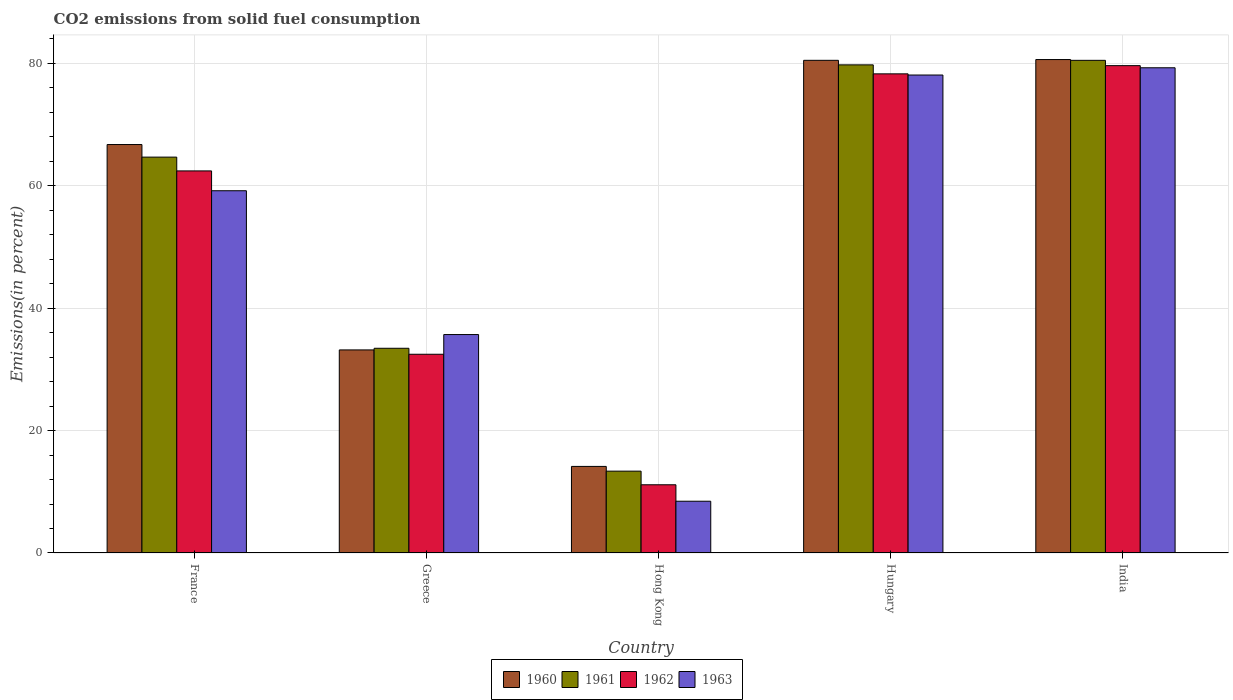Are the number of bars on each tick of the X-axis equal?
Your answer should be very brief. Yes. What is the label of the 4th group of bars from the left?
Give a very brief answer. Hungary. In how many cases, is the number of bars for a given country not equal to the number of legend labels?
Your response must be concise. 0. What is the total CO2 emitted in 1961 in India?
Offer a terse response. 80.49. Across all countries, what is the maximum total CO2 emitted in 1961?
Your answer should be very brief. 80.49. Across all countries, what is the minimum total CO2 emitted in 1963?
Provide a succinct answer. 8.46. In which country was the total CO2 emitted in 1963 maximum?
Provide a short and direct response. India. In which country was the total CO2 emitted in 1961 minimum?
Your response must be concise. Hong Kong. What is the total total CO2 emitted in 1960 in the graph?
Make the answer very short. 275.16. What is the difference between the total CO2 emitted in 1962 in Hong Kong and that in India?
Keep it short and to the point. -68.47. What is the difference between the total CO2 emitted in 1963 in Greece and the total CO2 emitted in 1960 in India?
Ensure brevity in your answer.  -44.93. What is the average total CO2 emitted in 1962 per country?
Keep it short and to the point. 52.79. What is the difference between the total CO2 emitted of/in 1963 and total CO2 emitted of/in 1962 in Greece?
Your response must be concise. 3.22. In how many countries, is the total CO2 emitted in 1961 greater than 60 %?
Make the answer very short. 3. What is the ratio of the total CO2 emitted in 1962 in Greece to that in India?
Provide a succinct answer. 0.41. What is the difference between the highest and the second highest total CO2 emitted in 1960?
Keep it short and to the point. 13.88. What is the difference between the highest and the lowest total CO2 emitted in 1960?
Provide a succinct answer. 66.47. In how many countries, is the total CO2 emitted in 1963 greater than the average total CO2 emitted in 1963 taken over all countries?
Provide a short and direct response. 3. Is it the case that in every country, the sum of the total CO2 emitted in 1963 and total CO2 emitted in 1962 is greater than the sum of total CO2 emitted in 1960 and total CO2 emitted in 1961?
Keep it short and to the point. No. What does the 3rd bar from the left in Greece represents?
Provide a succinct answer. 1962. Is it the case that in every country, the sum of the total CO2 emitted in 1961 and total CO2 emitted in 1962 is greater than the total CO2 emitted in 1960?
Offer a very short reply. Yes. How many countries are there in the graph?
Keep it short and to the point. 5. Does the graph contain grids?
Make the answer very short. Yes. Where does the legend appear in the graph?
Offer a very short reply. Bottom center. How many legend labels are there?
Provide a short and direct response. 4. What is the title of the graph?
Offer a very short reply. CO2 emissions from solid fuel consumption. What is the label or title of the X-axis?
Your answer should be compact. Country. What is the label or title of the Y-axis?
Make the answer very short. Emissions(in percent). What is the Emissions(in percent) in 1960 in France?
Provide a succinct answer. 66.73. What is the Emissions(in percent) of 1961 in France?
Offer a terse response. 64.68. What is the Emissions(in percent) of 1962 in France?
Your response must be concise. 62.42. What is the Emissions(in percent) in 1963 in France?
Ensure brevity in your answer.  59.18. What is the Emissions(in percent) in 1960 in Greece?
Ensure brevity in your answer.  33.18. What is the Emissions(in percent) of 1961 in Greece?
Your response must be concise. 33.45. What is the Emissions(in percent) in 1962 in Greece?
Offer a terse response. 32.47. What is the Emissions(in percent) of 1963 in Greece?
Provide a short and direct response. 35.69. What is the Emissions(in percent) of 1960 in Hong Kong?
Keep it short and to the point. 14.14. What is the Emissions(in percent) in 1961 in Hong Kong?
Offer a terse response. 13.37. What is the Emissions(in percent) of 1962 in Hong Kong?
Ensure brevity in your answer.  11.14. What is the Emissions(in percent) of 1963 in Hong Kong?
Make the answer very short. 8.46. What is the Emissions(in percent) of 1960 in Hungary?
Keep it short and to the point. 80.49. What is the Emissions(in percent) of 1961 in Hungary?
Your answer should be very brief. 79.75. What is the Emissions(in percent) of 1962 in Hungary?
Provide a short and direct response. 78.28. What is the Emissions(in percent) in 1963 in Hungary?
Offer a very short reply. 78.09. What is the Emissions(in percent) of 1960 in India?
Ensure brevity in your answer.  80.62. What is the Emissions(in percent) of 1961 in India?
Offer a terse response. 80.49. What is the Emissions(in percent) in 1962 in India?
Keep it short and to the point. 79.62. What is the Emissions(in percent) of 1963 in India?
Provide a short and direct response. 79.27. Across all countries, what is the maximum Emissions(in percent) of 1960?
Your answer should be very brief. 80.62. Across all countries, what is the maximum Emissions(in percent) in 1961?
Provide a succinct answer. 80.49. Across all countries, what is the maximum Emissions(in percent) in 1962?
Provide a short and direct response. 79.62. Across all countries, what is the maximum Emissions(in percent) of 1963?
Provide a succinct answer. 79.27. Across all countries, what is the minimum Emissions(in percent) in 1960?
Your answer should be compact. 14.14. Across all countries, what is the minimum Emissions(in percent) in 1961?
Your response must be concise. 13.37. Across all countries, what is the minimum Emissions(in percent) of 1962?
Your response must be concise. 11.14. Across all countries, what is the minimum Emissions(in percent) of 1963?
Ensure brevity in your answer.  8.46. What is the total Emissions(in percent) of 1960 in the graph?
Ensure brevity in your answer.  275.16. What is the total Emissions(in percent) of 1961 in the graph?
Give a very brief answer. 271.72. What is the total Emissions(in percent) of 1962 in the graph?
Your answer should be very brief. 263.93. What is the total Emissions(in percent) in 1963 in the graph?
Your answer should be compact. 260.68. What is the difference between the Emissions(in percent) in 1960 in France and that in Greece?
Offer a very short reply. 33.55. What is the difference between the Emissions(in percent) of 1961 in France and that in Greece?
Your answer should be very brief. 31.23. What is the difference between the Emissions(in percent) of 1962 in France and that in Greece?
Offer a very short reply. 29.95. What is the difference between the Emissions(in percent) in 1963 in France and that in Greece?
Keep it short and to the point. 23.49. What is the difference between the Emissions(in percent) of 1960 in France and that in Hong Kong?
Keep it short and to the point. 52.59. What is the difference between the Emissions(in percent) in 1961 in France and that in Hong Kong?
Your answer should be compact. 51.31. What is the difference between the Emissions(in percent) in 1962 in France and that in Hong Kong?
Ensure brevity in your answer.  51.28. What is the difference between the Emissions(in percent) in 1963 in France and that in Hong Kong?
Ensure brevity in your answer.  50.73. What is the difference between the Emissions(in percent) of 1960 in France and that in Hungary?
Keep it short and to the point. -13.76. What is the difference between the Emissions(in percent) in 1961 in France and that in Hungary?
Provide a short and direct response. -15.07. What is the difference between the Emissions(in percent) of 1962 in France and that in Hungary?
Provide a short and direct response. -15.86. What is the difference between the Emissions(in percent) of 1963 in France and that in Hungary?
Your response must be concise. -18.91. What is the difference between the Emissions(in percent) of 1960 in France and that in India?
Make the answer very short. -13.88. What is the difference between the Emissions(in percent) in 1961 in France and that in India?
Keep it short and to the point. -15.81. What is the difference between the Emissions(in percent) in 1962 in France and that in India?
Provide a short and direct response. -17.2. What is the difference between the Emissions(in percent) of 1963 in France and that in India?
Ensure brevity in your answer.  -20.09. What is the difference between the Emissions(in percent) in 1960 in Greece and that in Hong Kong?
Provide a short and direct response. 19.03. What is the difference between the Emissions(in percent) in 1961 in Greece and that in Hong Kong?
Provide a succinct answer. 20.08. What is the difference between the Emissions(in percent) of 1962 in Greece and that in Hong Kong?
Offer a terse response. 21.32. What is the difference between the Emissions(in percent) in 1963 in Greece and that in Hong Kong?
Offer a terse response. 27.23. What is the difference between the Emissions(in percent) in 1960 in Greece and that in Hungary?
Provide a short and direct response. -47.31. What is the difference between the Emissions(in percent) in 1961 in Greece and that in Hungary?
Your answer should be very brief. -46.3. What is the difference between the Emissions(in percent) of 1962 in Greece and that in Hungary?
Keep it short and to the point. -45.81. What is the difference between the Emissions(in percent) of 1963 in Greece and that in Hungary?
Ensure brevity in your answer.  -42.4. What is the difference between the Emissions(in percent) in 1960 in Greece and that in India?
Offer a terse response. -47.44. What is the difference between the Emissions(in percent) in 1961 in Greece and that in India?
Your response must be concise. -47.04. What is the difference between the Emissions(in percent) in 1962 in Greece and that in India?
Offer a very short reply. -47.15. What is the difference between the Emissions(in percent) in 1963 in Greece and that in India?
Keep it short and to the point. -43.58. What is the difference between the Emissions(in percent) in 1960 in Hong Kong and that in Hungary?
Make the answer very short. -66.35. What is the difference between the Emissions(in percent) of 1961 in Hong Kong and that in Hungary?
Provide a short and direct response. -66.38. What is the difference between the Emissions(in percent) in 1962 in Hong Kong and that in Hungary?
Give a very brief answer. -67.13. What is the difference between the Emissions(in percent) in 1963 in Hong Kong and that in Hungary?
Keep it short and to the point. -69.63. What is the difference between the Emissions(in percent) in 1960 in Hong Kong and that in India?
Provide a succinct answer. -66.47. What is the difference between the Emissions(in percent) of 1961 in Hong Kong and that in India?
Keep it short and to the point. -67.12. What is the difference between the Emissions(in percent) of 1962 in Hong Kong and that in India?
Give a very brief answer. -68.47. What is the difference between the Emissions(in percent) of 1963 in Hong Kong and that in India?
Keep it short and to the point. -70.82. What is the difference between the Emissions(in percent) of 1960 in Hungary and that in India?
Provide a succinct answer. -0.13. What is the difference between the Emissions(in percent) of 1961 in Hungary and that in India?
Your answer should be very brief. -0.74. What is the difference between the Emissions(in percent) in 1962 in Hungary and that in India?
Provide a short and direct response. -1.34. What is the difference between the Emissions(in percent) in 1963 in Hungary and that in India?
Offer a terse response. -1.18. What is the difference between the Emissions(in percent) in 1960 in France and the Emissions(in percent) in 1961 in Greece?
Your answer should be very brief. 33.29. What is the difference between the Emissions(in percent) of 1960 in France and the Emissions(in percent) of 1962 in Greece?
Provide a succinct answer. 34.26. What is the difference between the Emissions(in percent) in 1960 in France and the Emissions(in percent) in 1963 in Greece?
Your answer should be compact. 31.05. What is the difference between the Emissions(in percent) of 1961 in France and the Emissions(in percent) of 1962 in Greece?
Keep it short and to the point. 32.21. What is the difference between the Emissions(in percent) of 1961 in France and the Emissions(in percent) of 1963 in Greece?
Offer a terse response. 28.99. What is the difference between the Emissions(in percent) in 1962 in France and the Emissions(in percent) in 1963 in Greece?
Make the answer very short. 26.74. What is the difference between the Emissions(in percent) of 1960 in France and the Emissions(in percent) of 1961 in Hong Kong?
Make the answer very short. 53.36. What is the difference between the Emissions(in percent) of 1960 in France and the Emissions(in percent) of 1962 in Hong Kong?
Provide a succinct answer. 55.59. What is the difference between the Emissions(in percent) of 1960 in France and the Emissions(in percent) of 1963 in Hong Kong?
Your answer should be compact. 58.28. What is the difference between the Emissions(in percent) in 1961 in France and the Emissions(in percent) in 1962 in Hong Kong?
Ensure brevity in your answer.  53.53. What is the difference between the Emissions(in percent) of 1961 in France and the Emissions(in percent) of 1963 in Hong Kong?
Provide a short and direct response. 56.22. What is the difference between the Emissions(in percent) of 1962 in France and the Emissions(in percent) of 1963 in Hong Kong?
Provide a succinct answer. 53.97. What is the difference between the Emissions(in percent) of 1960 in France and the Emissions(in percent) of 1961 in Hungary?
Keep it short and to the point. -13.02. What is the difference between the Emissions(in percent) in 1960 in France and the Emissions(in percent) in 1962 in Hungary?
Your answer should be compact. -11.55. What is the difference between the Emissions(in percent) in 1960 in France and the Emissions(in percent) in 1963 in Hungary?
Your answer should be compact. -11.36. What is the difference between the Emissions(in percent) in 1961 in France and the Emissions(in percent) in 1962 in Hungary?
Give a very brief answer. -13.6. What is the difference between the Emissions(in percent) in 1961 in France and the Emissions(in percent) in 1963 in Hungary?
Offer a terse response. -13.41. What is the difference between the Emissions(in percent) of 1962 in France and the Emissions(in percent) of 1963 in Hungary?
Ensure brevity in your answer.  -15.67. What is the difference between the Emissions(in percent) of 1960 in France and the Emissions(in percent) of 1961 in India?
Give a very brief answer. -13.76. What is the difference between the Emissions(in percent) in 1960 in France and the Emissions(in percent) in 1962 in India?
Offer a terse response. -12.89. What is the difference between the Emissions(in percent) of 1960 in France and the Emissions(in percent) of 1963 in India?
Make the answer very short. -12.54. What is the difference between the Emissions(in percent) of 1961 in France and the Emissions(in percent) of 1962 in India?
Ensure brevity in your answer.  -14.94. What is the difference between the Emissions(in percent) in 1961 in France and the Emissions(in percent) in 1963 in India?
Offer a very short reply. -14.6. What is the difference between the Emissions(in percent) in 1962 in France and the Emissions(in percent) in 1963 in India?
Offer a terse response. -16.85. What is the difference between the Emissions(in percent) in 1960 in Greece and the Emissions(in percent) in 1961 in Hong Kong?
Keep it short and to the point. 19.81. What is the difference between the Emissions(in percent) in 1960 in Greece and the Emissions(in percent) in 1962 in Hong Kong?
Make the answer very short. 22.03. What is the difference between the Emissions(in percent) of 1960 in Greece and the Emissions(in percent) of 1963 in Hong Kong?
Your response must be concise. 24.72. What is the difference between the Emissions(in percent) in 1961 in Greece and the Emissions(in percent) in 1962 in Hong Kong?
Ensure brevity in your answer.  22.3. What is the difference between the Emissions(in percent) in 1961 in Greece and the Emissions(in percent) in 1963 in Hong Kong?
Provide a succinct answer. 24.99. What is the difference between the Emissions(in percent) of 1962 in Greece and the Emissions(in percent) of 1963 in Hong Kong?
Give a very brief answer. 24.01. What is the difference between the Emissions(in percent) in 1960 in Greece and the Emissions(in percent) in 1961 in Hungary?
Give a very brief answer. -46.57. What is the difference between the Emissions(in percent) of 1960 in Greece and the Emissions(in percent) of 1962 in Hungary?
Your answer should be compact. -45.1. What is the difference between the Emissions(in percent) of 1960 in Greece and the Emissions(in percent) of 1963 in Hungary?
Give a very brief answer. -44.91. What is the difference between the Emissions(in percent) of 1961 in Greece and the Emissions(in percent) of 1962 in Hungary?
Give a very brief answer. -44.83. What is the difference between the Emissions(in percent) in 1961 in Greece and the Emissions(in percent) in 1963 in Hungary?
Provide a short and direct response. -44.64. What is the difference between the Emissions(in percent) in 1962 in Greece and the Emissions(in percent) in 1963 in Hungary?
Your answer should be very brief. -45.62. What is the difference between the Emissions(in percent) of 1960 in Greece and the Emissions(in percent) of 1961 in India?
Ensure brevity in your answer.  -47.31. What is the difference between the Emissions(in percent) of 1960 in Greece and the Emissions(in percent) of 1962 in India?
Provide a succinct answer. -46.44. What is the difference between the Emissions(in percent) of 1960 in Greece and the Emissions(in percent) of 1963 in India?
Keep it short and to the point. -46.09. What is the difference between the Emissions(in percent) of 1961 in Greece and the Emissions(in percent) of 1962 in India?
Ensure brevity in your answer.  -46.17. What is the difference between the Emissions(in percent) in 1961 in Greece and the Emissions(in percent) in 1963 in India?
Provide a succinct answer. -45.83. What is the difference between the Emissions(in percent) in 1962 in Greece and the Emissions(in percent) in 1963 in India?
Provide a succinct answer. -46.8. What is the difference between the Emissions(in percent) in 1960 in Hong Kong and the Emissions(in percent) in 1961 in Hungary?
Keep it short and to the point. -65.6. What is the difference between the Emissions(in percent) of 1960 in Hong Kong and the Emissions(in percent) of 1962 in Hungary?
Make the answer very short. -64.13. What is the difference between the Emissions(in percent) in 1960 in Hong Kong and the Emissions(in percent) in 1963 in Hungary?
Keep it short and to the point. -63.94. What is the difference between the Emissions(in percent) of 1961 in Hong Kong and the Emissions(in percent) of 1962 in Hungary?
Keep it short and to the point. -64.91. What is the difference between the Emissions(in percent) in 1961 in Hong Kong and the Emissions(in percent) in 1963 in Hungary?
Make the answer very short. -64.72. What is the difference between the Emissions(in percent) in 1962 in Hong Kong and the Emissions(in percent) in 1963 in Hungary?
Your answer should be very brief. -66.94. What is the difference between the Emissions(in percent) of 1960 in Hong Kong and the Emissions(in percent) of 1961 in India?
Your answer should be compact. -66.34. What is the difference between the Emissions(in percent) of 1960 in Hong Kong and the Emissions(in percent) of 1962 in India?
Keep it short and to the point. -65.47. What is the difference between the Emissions(in percent) of 1960 in Hong Kong and the Emissions(in percent) of 1963 in India?
Offer a very short reply. -65.13. What is the difference between the Emissions(in percent) of 1961 in Hong Kong and the Emissions(in percent) of 1962 in India?
Provide a short and direct response. -66.25. What is the difference between the Emissions(in percent) of 1961 in Hong Kong and the Emissions(in percent) of 1963 in India?
Provide a short and direct response. -65.9. What is the difference between the Emissions(in percent) in 1962 in Hong Kong and the Emissions(in percent) in 1963 in India?
Provide a succinct answer. -68.13. What is the difference between the Emissions(in percent) in 1960 in Hungary and the Emissions(in percent) in 1961 in India?
Give a very brief answer. 0. What is the difference between the Emissions(in percent) in 1960 in Hungary and the Emissions(in percent) in 1962 in India?
Keep it short and to the point. 0.87. What is the difference between the Emissions(in percent) in 1960 in Hungary and the Emissions(in percent) in 1963 in India?
Ensure brevity in your answer.  1.22. What is the difference between the Emissions(in percent) of 1961 in Hungary and the Emissions(in percent) of 1962 in India?
Offer a terse response. 0.13. What is the difference between the Emissions(in percent) of 1961 in Hungary and the Emissions(in percent) of 1963 in India?
Provide a short and direct response. 0.48. What is the difference between the Emissions(in percent) in 1962 in Hungary and the Emissions(in percent) in 1963 in India?
Keep it short and to the point. -0.99. What is the average Emissions(in percent) in 1960 per country?
Make the answer very short. 55.03. What is the average Emissions(in percent) in 1961 per country?
Your response must be concise. 54.34. What is the average Emissions(in percent) of 1962 per country?
Keep it short and to the point. 52.79. What is the average Emissions(in percent) of 1963 per country?
Provide a succinct answer. 52.14. What is the difference between the Emissions(in percent) in 1960 and Emissions(in percent) in 1961 in France?
Provide a short and direct response. 2.06. What is the difference between the Emissions(in percent) of 1960 and Emissions(in percent) of 1962 in France?
Offer a terse response. 4.31. What is the difference between the Emissions(in percent) in 1960 and Emissions(in percent) in 1963 in France?
Your response must be concise. 7.55. What is the difference between the Emissions(in percent) in 1961 and Emissions(in percent) in 1962 in France?
Your answer should be very brief. 2.25. What is the difference between the Emissions(in percent) in 1961 and Emissions(in percent) in 1963 in France?
Provide a succinct answer. 5.49. What is the difference between the Emissions(in percent) of 1962 and Emissions(in percent) of 1963 in France?
Make the answer very short. 3.24. What is the difference between the Emissions(in percent) of 1960 and Emissions(in percent) of 1961 in Greece?
Keep it short and to the point. -0.27. What is the difference between the Emissions(in percent) in 1960 and Emissions(in percent) in 1962 in Greece?
Offer a terse response. 0.71. What is the difference between the Emissions(in percent) in 1960 and Emissions(in percent) in 1963 in Greece?
Provide a short and direct response. -2.51. What is the difference between the Emissions(in percent) of 1961 and Emissions(in percent) of 1962 in Greece?
Provide a succinct answer. 0.98. What is the difference between the Emissions(in percent) of 1961 and Emissions(in percent) of 1963 in Greece?
Make the answer very short. -2.24. What is the difference between the Emissions(in percent) in 1962 and Emissions(in percent) in 1963 in Greece?
Keep it short and to the point. -3.22. What is the difference between the Emissions(in percent) of 1960 and Emissions(in percent) of 1961 in Hong Kong?
Provide a succinct answer. 0.77. What is the difference between the Emissions(in percent) in 1960 and Emissions(in percent) in 1962 in Hong Kong?
Your answer should be compact. 3. What is the difference between the Emissions(in percent) of 1960 and Emissions(in percent) of 1963 in Hong Kong?
Your answer should be very brief. 5.69. What is the difference between the Emissions(in percent) in 1961 and Emissions(in percent) in 1962 in Hong Kong?
Make the answer very short. 2.23. What is the difference between the Emissions(in percent) of 1961 and Emissions(in percent) of 1963 in Hong Kong?
Ensure brevity in your answer.  4.91. What is the difference between the Emissions(in percent) in 1962 and Emissions(in percent) in 1963 in Hong Kong?
Provide a succinct answer. 2.69. What is the difference between the Emissions(in percent) in 1960 and Emissions(in percent) in 1961 in Hungary?
Provide a short and direct response. 0.74. What is the difference between the Emissions(in percent) of 1960 and Emissions(in percent) of 1962 in Hungary?
Make the answer very short. 2.21. What is the difference between the Emissions(in percent) in 1960 and Emissions(in percent) in 1963 in Hungary?
Provide a succinct answer. 2.4. What is the difference between the Emissions(in percent) of 1961 and Emissions(in percent) of 1962 in Hungary?
Offer a terse response. 1.47. What is the difference between the Emissions(in percent) in 1961 and Emissions(in percent) in 1963 in Hungary?
Make the answer very short. 1.66. What is the difference between the Emissions(in percent) in 1962 and Emissions(in percent) in 1963 in Hungary?
Keep it short and to the point. 0.19. What is the difference between the Emissions(in percent) of 1960 and Emissions(in percent) of 1961 in India?
Give a very brief answer. 0.13. What is the difference between the Emissions(in percent) of 1960 and Emissions(in percent) of 1962 in India?
Provide a succinct answer. 1. What is the difference between the Emissions(in percent) in 1960 and Emissions(in percent) in 1963 in India?
Provide a succinct answer. 1.34. What is the difference between the Emissions(in percent) in 1961 and Emissions(in percent) in 1962 in India?
Keep it short and to the point. 0.87. What is the difference between the Emissions(in percent) in 1961 and Emissions(in percent) in 1963 in India?
Provide a succinct answer. 1.22. What is the difference between the Emissions(in percent) of 1962 and Emissions(in percent) of 1963 in India?
Offer a very short reply. 0.35. What is the ratio of the Emissions(in percent) in 1960 in France to that in Greece?
Offer a terse response. 2.01. What is the ratio of the Emissions(in percent) of 1961 in France to that in Greece?
Offer a terse response. 1.93. What is the ratio of the Emissions(in percent) in 1962 in France to that in Greece?
Give a very brief answer. 1.92. What is the ratio of the Emissions(in percent) in 1963 in France to that in Greece?
Your response must be concise. 1.66. What is the ratio of the Emissions(in percent) of 1960 in France to that in Hong Kong?
Keep it short and to the point. 4.72. What is the ratio of the Emissions(in percent) of 1961 in France to that in Hong Kong?
Your answer should be compact. 4.84. What is the ratio of the Emissions(in percent) in 1962 in France to that in Hong Kong?
Provide a short and direct response. 5.6. What is the ratio of the Emissions(in percent) in 1963 in France to that in Hong Kong?
Provide a short and direct response. 7. What is the ratio of the Emissions(in percent) of 1960 in France to that in Hungary?
Ensure brevity in your answer.  0.83. What is the ratio of the Emissions(in percent) of 1961 in France to that in Hungary?
Your response must be concise. 0.81. What is the ratio of the Emissions(in percent) in 1962 in France to that in Hungary?
Make the answer very short. 0.8. What is the ratio of the Emissions(in percent) of 1963 in France to that in Hungary?
Keep it short and to the point. 0.76. What is the ratio of the Emissions(in percent) in 1960 in France to that in India?
Give a very brief answer. 0.83. What is the ratio of the Emissions(in percent) in 1961 in France to that in India?
Provide a short and direct response. 0.8. What is the ratio of the Emissions(in percent) of 1962 in France to that in India?
Ensure brevity in your answer.  0.78. What is the ratio of the Emissions(in percent) of 1963 in France to that in India?
Give a very brief answer. 0.75. What is the ratio of the Emissions(in percent) in 1960 in Greece to that in Hong Kong?
Your answer should be compact. 2.35. What is the ratio of the Emissions(in percent) of 1961 in Greece to that in Hong Kong?
Offer a terse response. 2.5. What is the ratio of the Emissions(in percent) in 1962 in Greece to that in Hong Kong?
Keep it short and to the point. 2.91. What is the ratio of the Emissions(in percent) in 1963 in Greece to that in Hong Kong?
Make the answer very short. 4.22. What is the ratio of the Emissions(in percent) of 1960 in Greece to that in Hungary?
Make the answer very short. 0.41. What is the ratio of the Emissions(in percent) of 1961 in Greece to that in Hungary?
Provide a succinct answer. 0.42. What is the ratio of the Emissions(in percent) of 1962 in Greece to that in Hungary?
Your response must be concise. 0.41. What is the ratio of the Emissions(in percent) in 1963 in Greece to that in Hungary?
Keep it short and to the point. 0.46. What is the ratio of the Emissions(in percent) of 1960 in Greece to that in India?
Provide a succinct answer. 0.41. What is the ratio of the Emissions(in percent) in 1961 in Greece to that in India?
Offer a terse response. 0.42. What is the ratio of the Emissions(in percent) of 1962 in Greece to that in India?
Ensure brevity in your answer.  0.41. What is the ratio of the Emissions(in percent) of 1963 in Greece to that in India?
Your answer should be compact. 0.45. What is the ratio of the Emissions(in percent) in 1960 in Hong Kong to that in Hungary?
Make the answer very short. 0.18. What is the ratio of the Emissions(in percent) in 1961 in Hong Kong to that in Hungary?
Ensure brevity in your answer.  0.17. What is the ratio of the Emissions(in percent) in 1962 in Hong Kong to that in Hungary?
Keep it short and to the point. 0.14. What is the ratio of the Emissions(in percent) in 1963 in Hong Kong to that in Hungary?
Your answer should be very brief. 0.11. What is the ratio of the Emissions(in percent) in 1960 in Hong Kong to that in India?
Your response must be concise. 0.18. What is the ratio of the Emissions(in percent) of 1961 in Hong Kong to that in India?
Offer a very short reply. 0.17. What is the ratio of the Emissions(in percent) in 1962 in Hong Kong to that in India?
Provide a short and direct response. 0.14. What is the ratio of the Emissions(in percent) in 1963 in Hong Kong to that in India?
Keep it short and to the point. 0.11. What is the ratio of the Emissions(in percent) in 1961 in Hungary to that in India?
Keep it short and to the point. 0.99. What is the ratio of the Emissions(in percent) of 1962 in Hungary to that in India?
Your response must be concise. 0.98. What is the ratio of the Emissions(in percent) in 1963 in Hungary to that in India?
Your answer should be compact. 0.99. What is the difference between the highest and the second highest Emissions(in percent) of 1960?
Your answer should be compact. 0.13. What is the difference between the highest and the second highest Emissions(in percent) of 1961?
Keep it short and to the point. 0.74. What is the difference between the highest and the second highest Emissions(in percent) of 1962?
Ensure brevity in your answer.  1.34. What is the difference between the highest and the second highest Emissions(in percent) of 1963?
Keep it short and to the point. 1.18. What is the difference between the highest and the lowest Emissions(in percent) in 1960?
Your answer should be very brief. 66.47. What is the difference between the highest and the lowest Emissions(in percent) in 1961?
Offer a very short reply. 67.12. What is the difference between the highest and the lowest Emissions(in percent) of 1962?
Your answer should be compact. 68.47. What is the difference between the highest and the lowest Emissions(in percent) of 1963?
Make the answer very short. 70.82. 